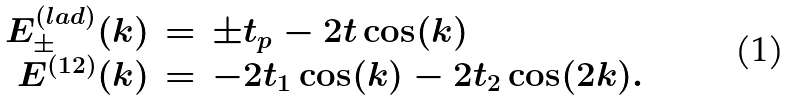Convert formula to latex. <formula><loc_0><loc_0><loc_500><loc_500>\begin{array} { r c l } E _ { \pm } ^ { ( l a d ) } ( k ) & = & \pm t _ { p } - 2 t \cos ( k ) \\ E ^ { ( 1 2 ) } ( k ) & = & - 2 t _ { 1 } \cos ( k ) - 2 t _ { 2 } \cos ( 2 k ) . \end{array}</formula> 